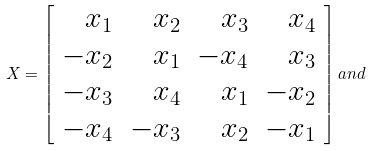Convert formula to latex. <formula><loc_0><loc_0><loc_500><loc_500>X = \left [ \begin{array} { r r r r } x _ { 1 } & x _ { 2 } & x _ { 3 } & x _ { 4 } \\ - x _ { 2 } & x _ { 1 } & - x _ { 4 } & x _ { 3 } \\ - x _ { 3 } & x _ { 4 } & x _ { 1 } & - x _ { 2 } \\ - x _ { 4 } & - x _ { 3 } & x _ { 2 } & - x _ { 1 } \\ \end{array} \right ] a n d</formula> 